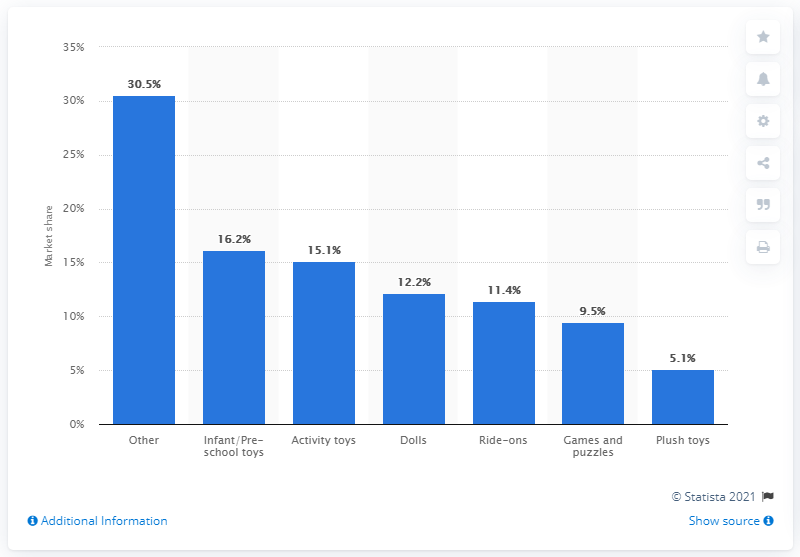Identify some key points in this picture. In 2009, activity toys accounted for approximately 15.1% of the total revenue generated by the toys and games market. According to data from 2009, activity toys accounted for 15.1 percent of the total revenue of the toys and games market. 